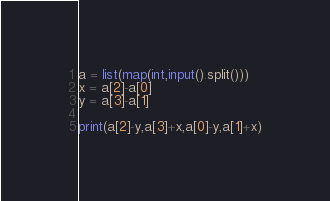<code> <loc_0><loc_0><loc_500><loc_500><_Python_>a = list(map(int,input().split()))
x = a[2]-a[0]
y = a[3]-a[1]

print(a[2]-y,a[3]+x,a[0]-y,a[1]+x)
</code> 